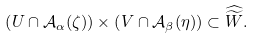Convert formula to latex. <formula><loc_0><loc_0><loc_500><loc_500>\left ( U \cap \mathcal { A } _ { \alpha } ( \zeta ) \right ) \times \left ( V \cap \mathcal { A } _ { \beta } ( \eta ) \right ) \subset \widehat { \widetilde { W } } .</formula> 